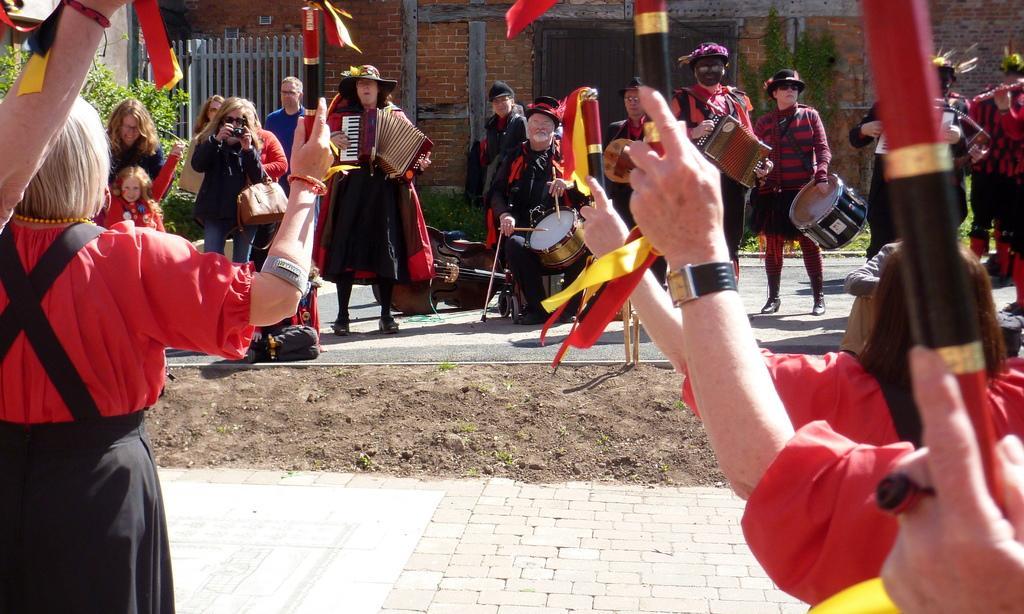Could you give a brief overview of what you see in this image? In this image there are persons playing musical instruments and standing. In the background there is a building, there are plants and there is a wooden fence and there is grass on the ground and the persons are holding flags. 